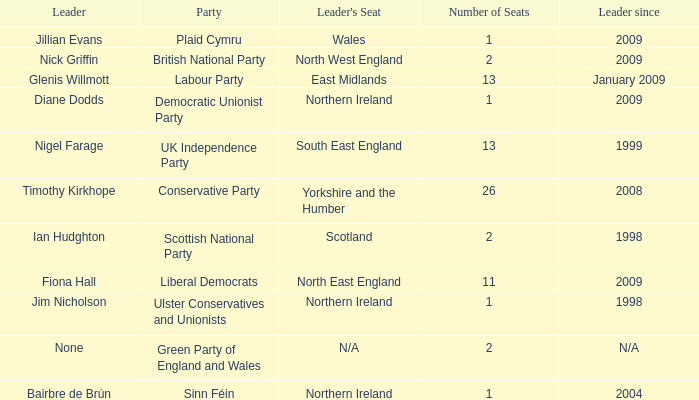What is Jillian Evans highest number of seats? 1.0. 